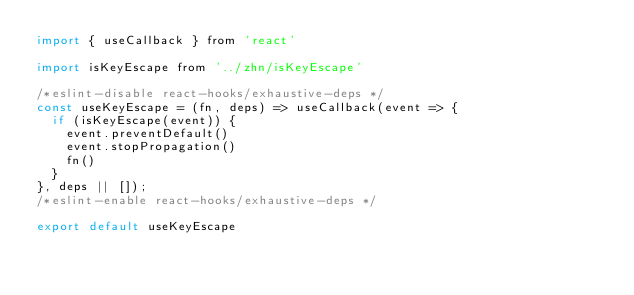Convert code to text. <code><loc_0><loc_0><loc_500><loc_500><_JavaScript_>import { useCallback } from 'react'

import isKeyEscape from '../zhn/isKeyEscape'

/*eslint-disable react-hooks/exhaustive-deps */
const useKeyEscape = (fn, deps) => useCallback(event => {
  if (isKeyEscape(event)) {
    event.preventDefault()
    event.stopPropagation()
    fn() 
  }
}, deps || []);
/*eslint-enable react-hooks/exhaustive-deps */

export default useKeyEscape
</code> 